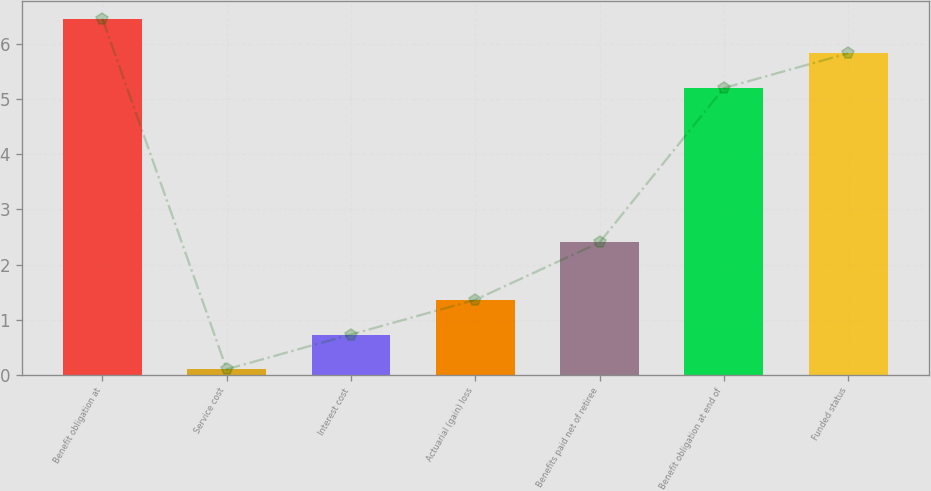<chart> <loc_0><loc_0><loc_500><loc_500><bar_chart><fcel>Benefit obligation at<fcel>Service cost<fcel>Interest cost<fcel>Actuarial (gain) loss<fcel>Benefits paid net of retiree<fcel>Benefit obligation at end of<fcel>Funded status<nl><fcel>6.46<fcel>0.1<fcel>0.73<fcel>1.36<fcel>2.4<fcel>5.2<fcel>5.83<nl></chart> 